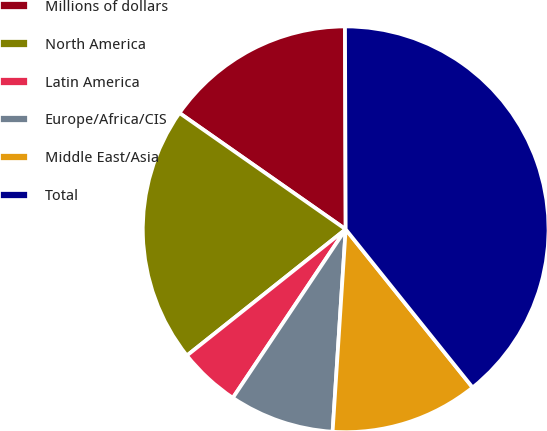Convert chart. <chart><loc_0><loc_0><loc_500><loc_500><pie_chart><fcel>Millions of dollars<fcel>North America<fcel>Latin America<fcel>Europe/Africa/CIS<fcel>Middle East/Asia<fcel>Total<nl><fcel>15.23%<fcel>20.41%<fcel>4.92%<fcel>8.36%<fcel>11.79%<fcel>39.29%<nl></chart> 